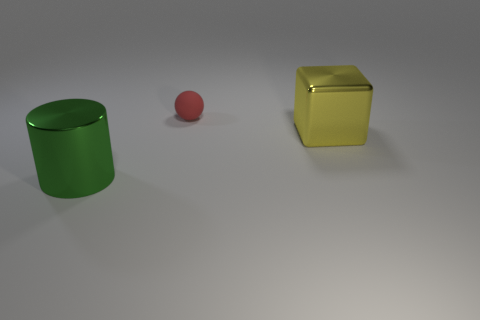Add 2 large green shiny objects. How many objects exist? 5 Subtract all balls. How many objects are left? 2 Subtract 0 purple cylinders. How many objects are left? 3 Subtract all large shiny cylinders. Subtract all big shiny objects. How many objects are left? 0 Add 2 tiny rubber balls. How many tiny rubber balls are left? 3 Add 3 big green cylinders. How many big green cylinders exist? 4 